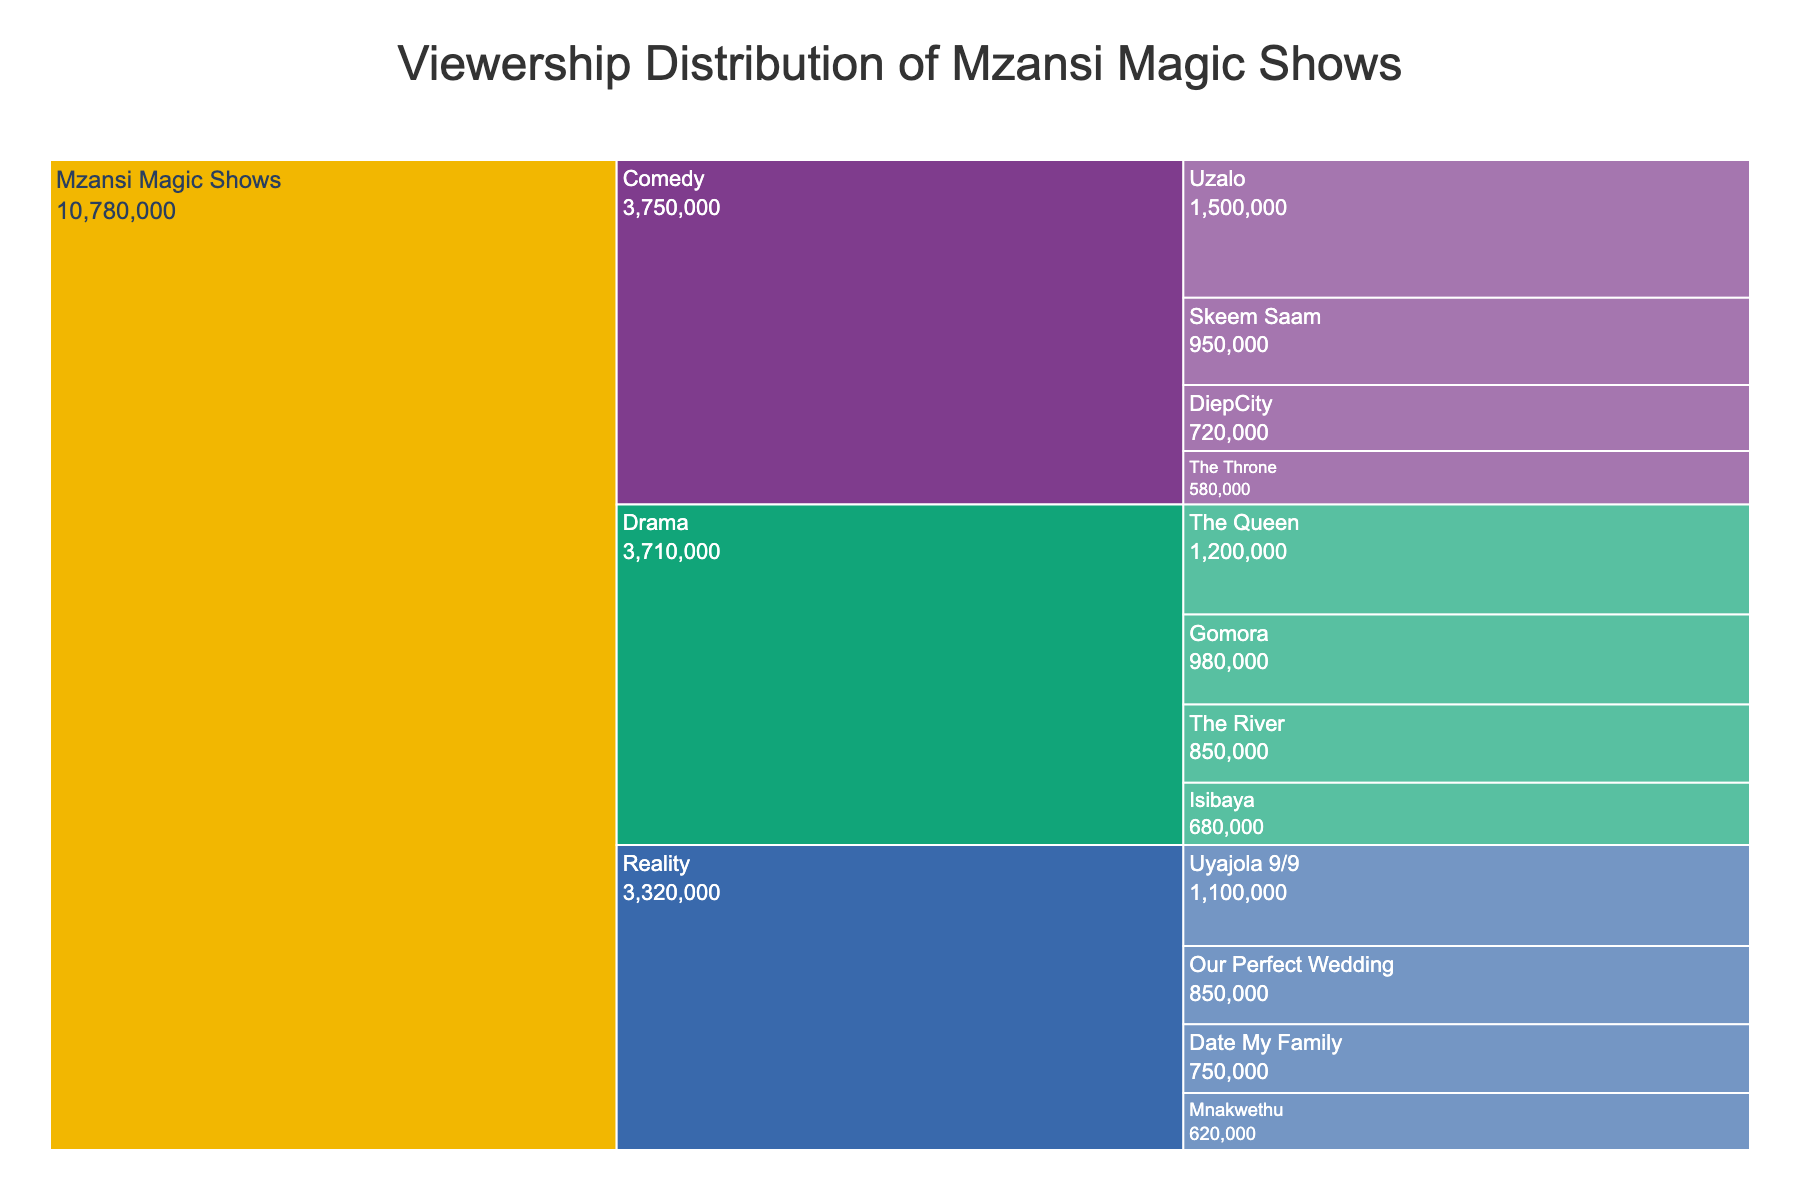What is the title of the figure? The title is usually located at the top of the figure and typically summarizes what the chart is depicting.
Answer: Viewership Distribution of Mzansi Magic Shows Which show has the highest viewership? To find the show with the highest viewership, look for the show with the largest numerical value under "Viewership".
Answer: Uzalo Which genre has the highest total viewership? Sum the viewership numbers for each genre and compare the totals. Drama, Reality, and Comedy are the genres.
Answer: Drama What is the combined viewership of all Drama shows? Add the viewership numbers for all Drama shows: The Queen, Gomora, The River, and Isibaya.
Answer: 3,430,000 Which genre has the smallest share of viewership? Compare the total viewership of each genre. The one with the smallest total is the genre with the smallest share.
Answer: Reality How does the viewership of The Queen compare to DiepCity? Compare the viewership values directly between The Queen and DiepCity.
Answer: The Queen has more viewership What is the average viewership per show in the Comedy genre? Sum the viewership numbers for all Comedy shows and divide by the number of Comedy shows.
Answer: 938,333 What share of the total viewership does Gomora contribute? To find Gomora's share, divide its viewership by the total viewership of all shows, then multiply by 100 to get the percentage.
Answer: 12.29% If you combine the viewership of Our Perfect Wedding and Date My Family, will it surpass that of The Queen? Add the viewership of Our Perfect Wedding and Date My Family, and compare their sum to the viewership of The Queen.
Answer: No 